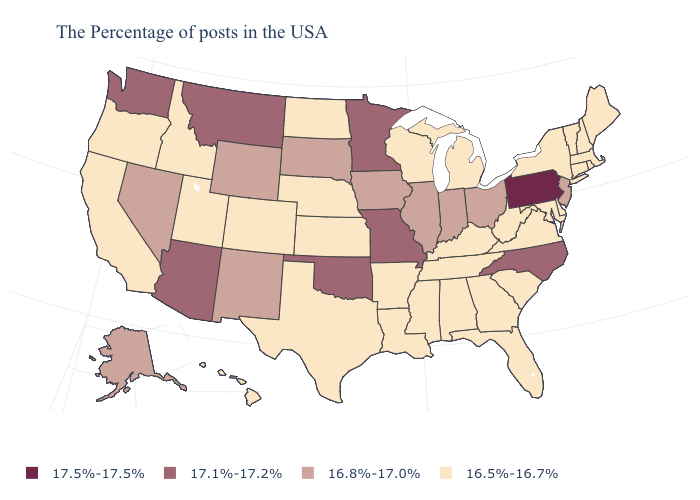Does Connecticut have the same value as California?
Quick response, please. Yes. Does Oregon have a lower value than Florida?
Concise answer only. No. What is the value of Alaska?
Give a very brief answer. 16.8%-17.0%. Name the states that have a value in the range 16.5%-16.7%?
Be succinct. Maine, Massachusetts, Rhode Island, New Hampshire, Vermont, Connecticut, New York, Delaware, Maryland, Virginia, South Carolina, West Virginia, Florida, Georgia, Michigan, Kentucky, Alabama, Tennessee, Wisconsin, Mississippi, Louisiana, Arkansas, Kansas, Nebraska, Texas, North Dakota, Colorado, Utah, Idaho, California, Oregon, Hawaii. Does Indiana have the same value as New Hampshire?
Short answer required. No. What is the value of Louisiana?
Quick response, please. 16.5%-16.7%. Name the states that have a value in the range 17.1%-17.2%?
Quick response, please. North Carolina, Missouri, Minnesota, Oklahoma, Montana, Arizona, Washington. Among the states that border Arkansas , does Oklahoma have the highest value?
Concise answer only. Yes. What is the value of Iowa?
Keep it brief. 16.8%-17.0%. Does Michigan have the lowest value in the MidWest?
Concise answer only. Yes. Does Indiana have a higher value than Kentucky?
Quick response, please. Yes. Name the states that have a value in the range 17.1%-17.2%?
Short answer required. North Carolina, Missouri, Minnesota, Oklahoma, Montana, Arizona, Washington. What is the lowest value in the USA?
Give a very brief answer. 16.5%-16.7%. Among the states that border Oregon , which have the lowest value?
Answer briefly. Idaho, California. 